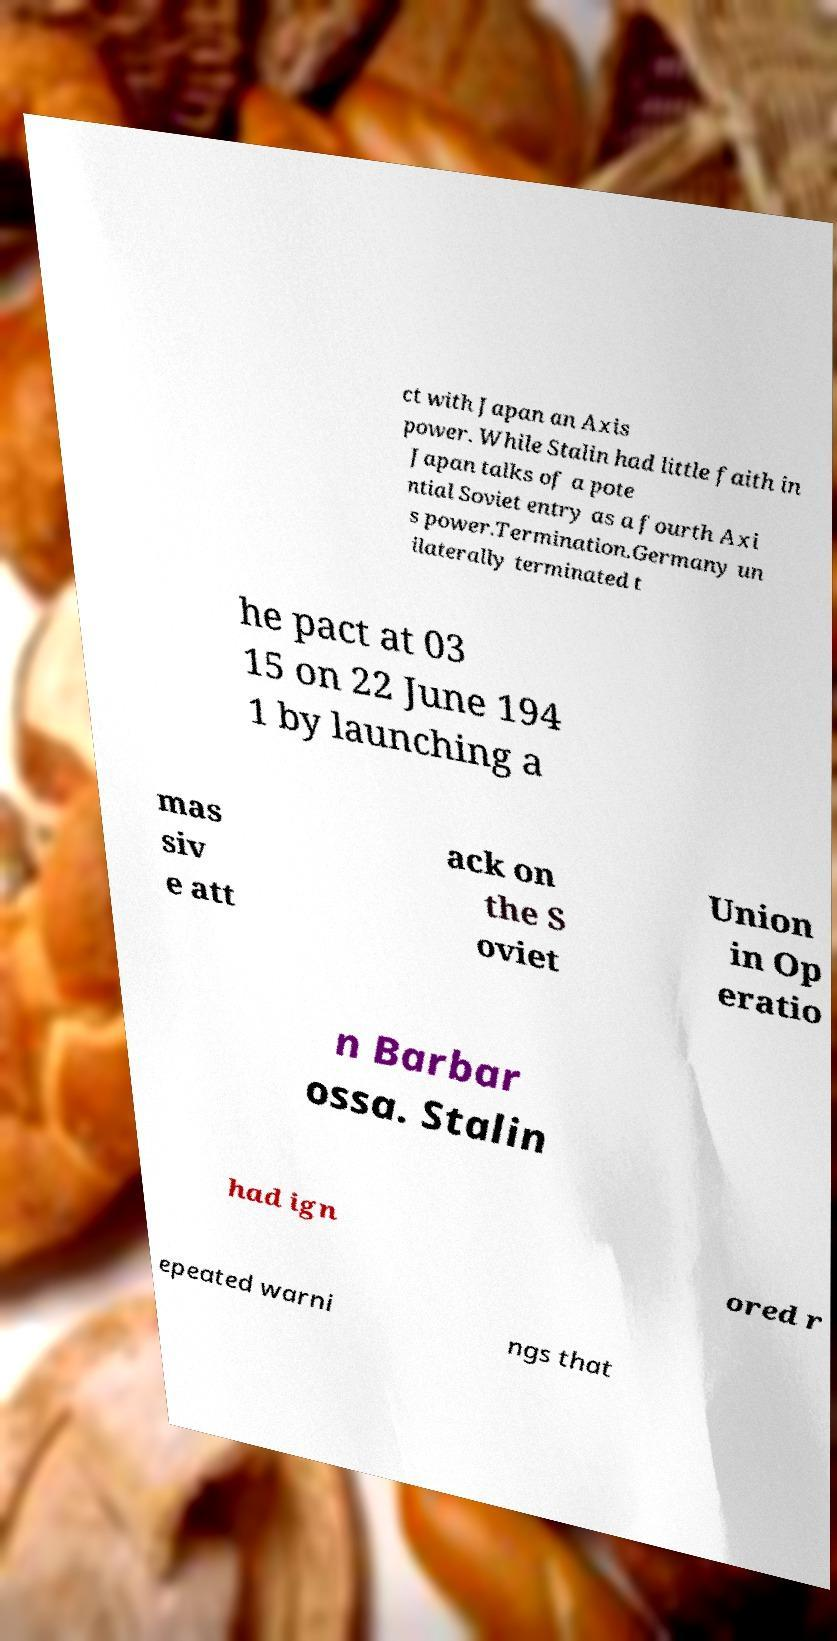Can you accurately transcribe the text from the provided image for me? ct with Japan an Axis power. While Stalin had little faith in Japan talks of a pote ntial Soviet entry as a fourth Axi s power.Termination.Germany un ilaterally terminated t he pact at 03 15 on 22 June 194 1 by launching a mas siv e att ack on the S oviet Union in Op eratio n Barbar ossa. Stalin had ign ored r epeated warni ngs that 